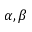Convert formula to latex. <formula><loc_0><loc_0><loc_500><loc_500>\alpha , \beta</formula> 